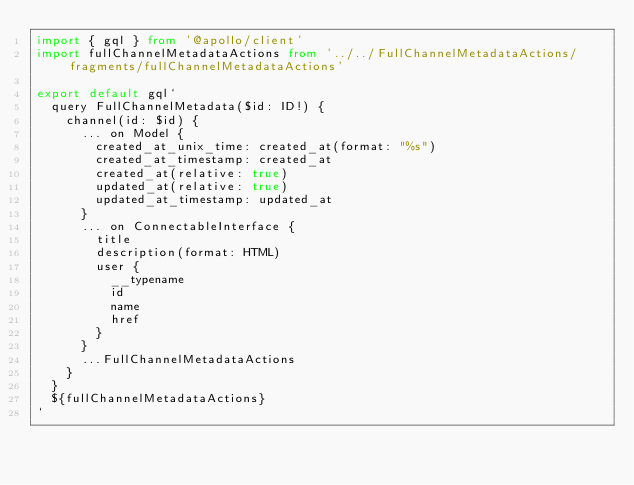Convert code to text. <code><loc_0><loc_0><loc_500><loc_500><_TypeScript_>import { gql } from '@apollo/client'
import fullChannelMetadataActions from '../../FullChannelMetadataActions/fragments/fullChannelMetadataActions'

export default gql`
  query FullChannelMetadata($id: ID!) {
    channel(id: $id) {
      ... on Model {
        created_at_unix_time: created_at(format: "%s")
        created_at_timestamp: created_at
        created_at(relative: true)
        updated_at(relative: true)
        updated_at_timestamp: updated_at
      }
      ... on ConnectableInterface {
        title
        description(format: HTML)
        user {
          __typename
          id
          name
          href
        }
      }
      ...FullChannelMetadataActions
    }
  }
  ${fullChannelMetadataActions}
`
</code> 